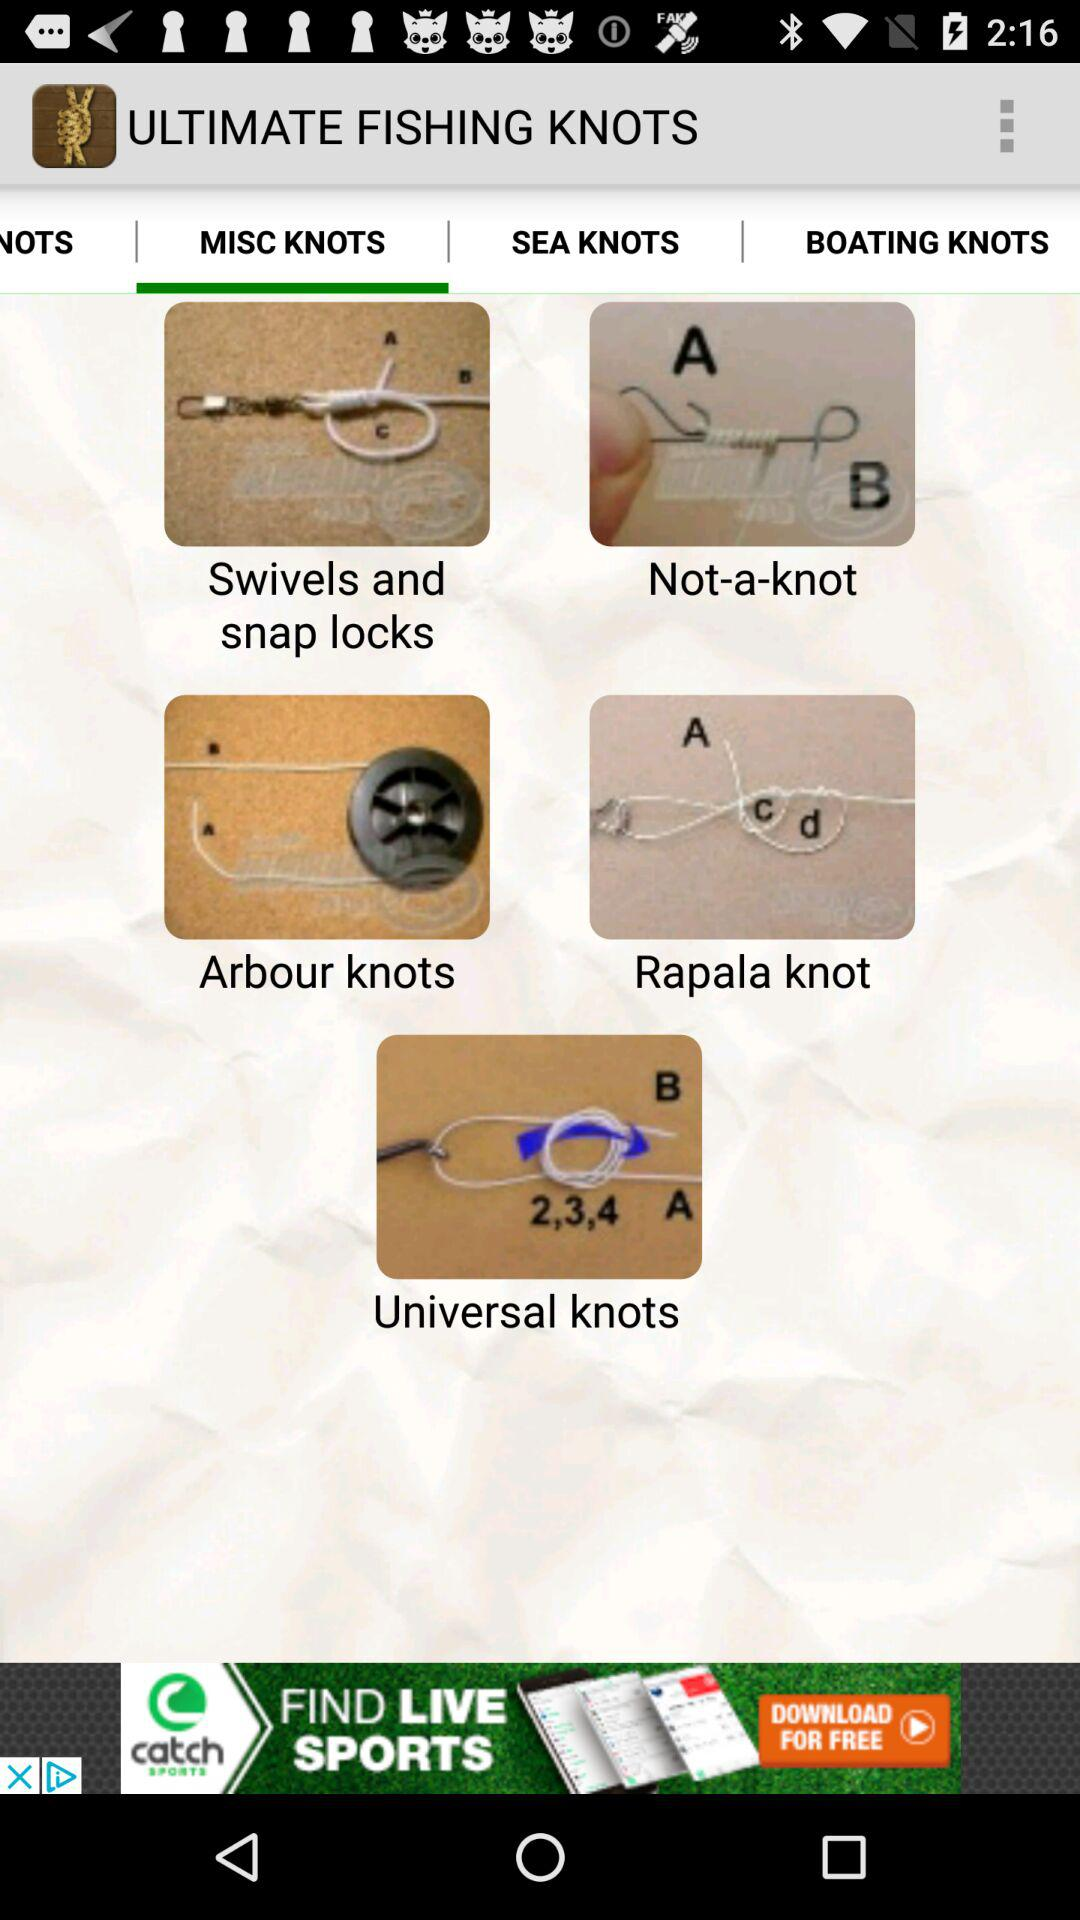What is the name of the application? The application name is "ULTIMATE FISHING KNOTS". 